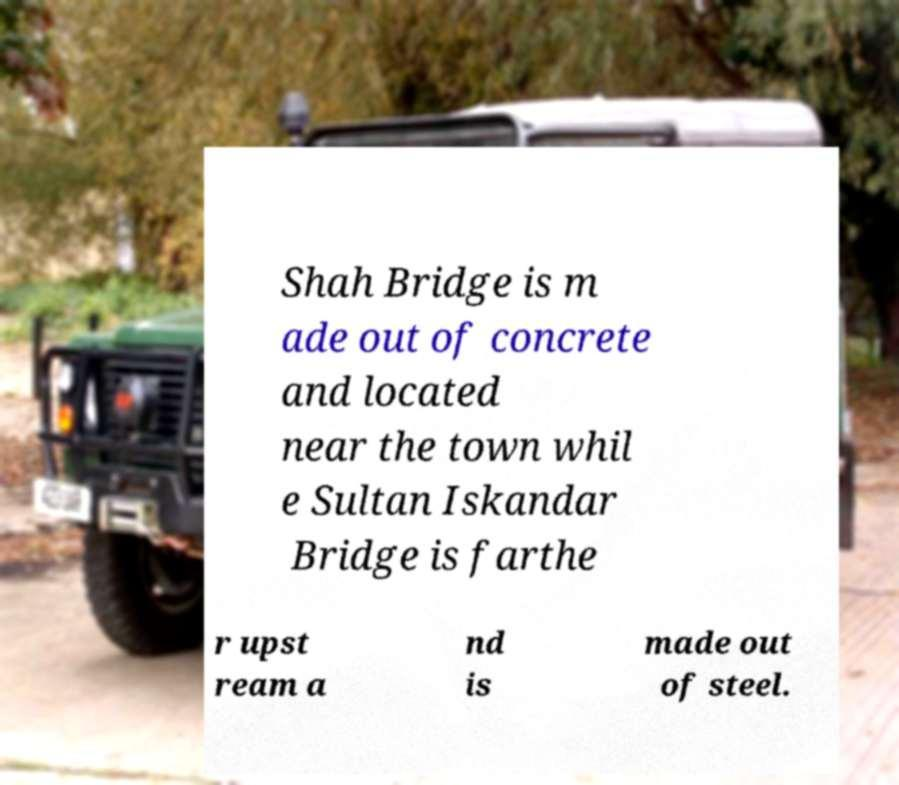I need the written content from this picture converted into text. Can you do that? Shah Bridge is m ade out of concrete and located near the town whil e Sultan Iskandar Bridge is farthe r upst ream a nd is made out of steel. 